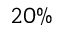<formula> <loc_0><loc_0><loc_500><loc_500>2 0 \%</formula> 